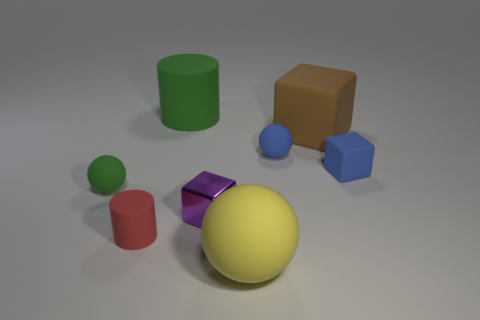Is the number of tiny balls that are behind the big brown rubber block greater than the number of tiny green things that are right of the big ball?
Offer a very short reply. No. What number of red matte cylinders have the same size as the red matte thing?
Provide a succinct answer. 0. Is the number of tiny blue rubber cubes on the left side of the green matte cylinder less than the number of yellow spheres that are behind the large brown rubber cube?
Ensure brevity in your answer.  No. Is there a red rubber object of the same shape as the small green thing?
Keep it short and to the point. No. Is the shape of the brown thing the same as the big green object?
Provide a short and direct response. No. How many large things are either blue objects or purple cylinders?
Your answer should be compact. 0. Are there more big blocks than tiny blue shiny cylinders?
Provide a succinct answer. Yes. What is the size of the blue block that is the same material as the brown thing?
Your response must be concise. Small. Is the size of the green matte object to the left of the large green rubber object the same as the matte cylinder in front of the big green rubber cylinder?
Provide a succinct answer. Yes. What number of things are either green matte objects to the left of the large green rubber object or small shiny blocks?
Provide a short and direct response. 2. 